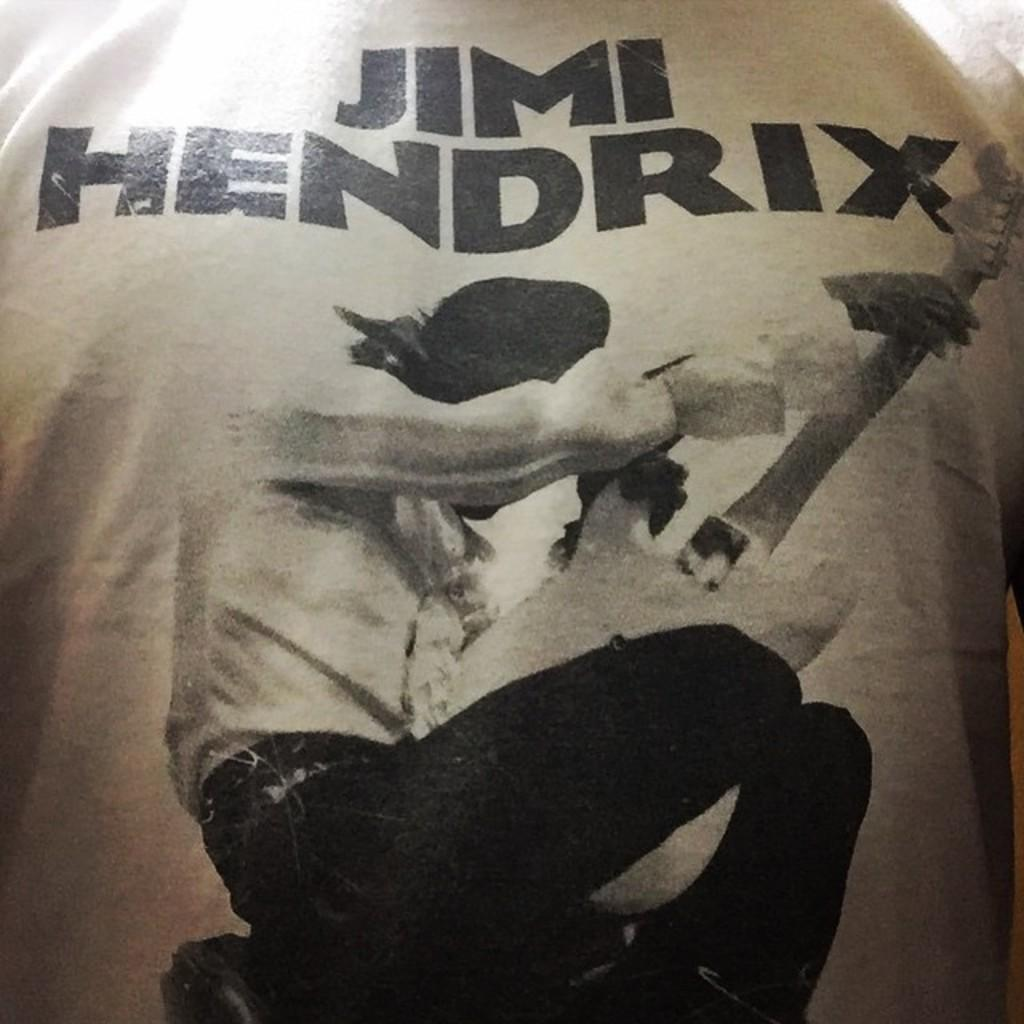What is depicted on the cloth in the image? There is a picture of a person on the cloth. What is the person in the picture holding? The person in the picture is holding a guitar. Are there any words or phrases on the cloth? Yes, there is text written on the cloth. What type of ball can be seen in the picture on the cloth? There is no ball present in the picture on the cloth; it features a person holding a guitar. Is there a net visible in the image? No, there is no net present in the image. 